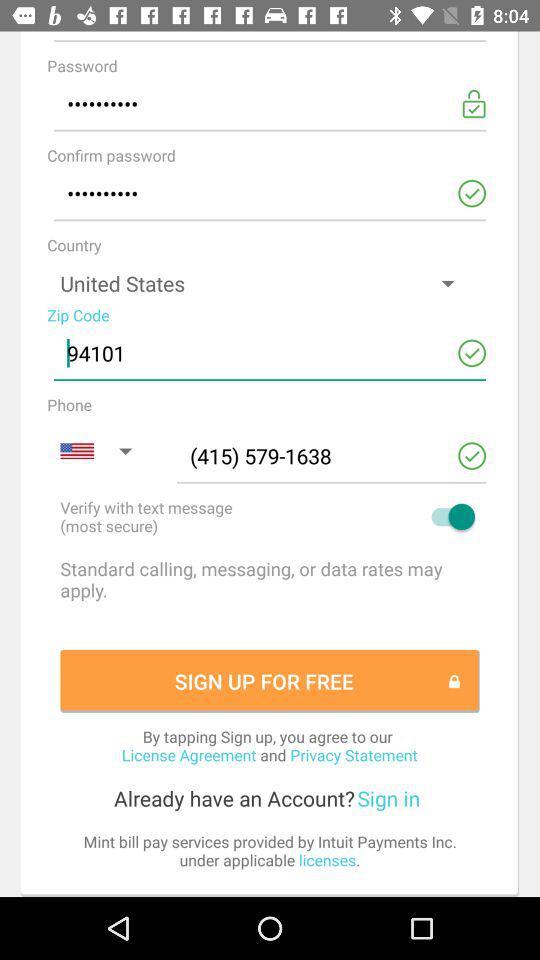What is the status of the "Verify with text message"? The status of the "Verify with text message" is "on". 